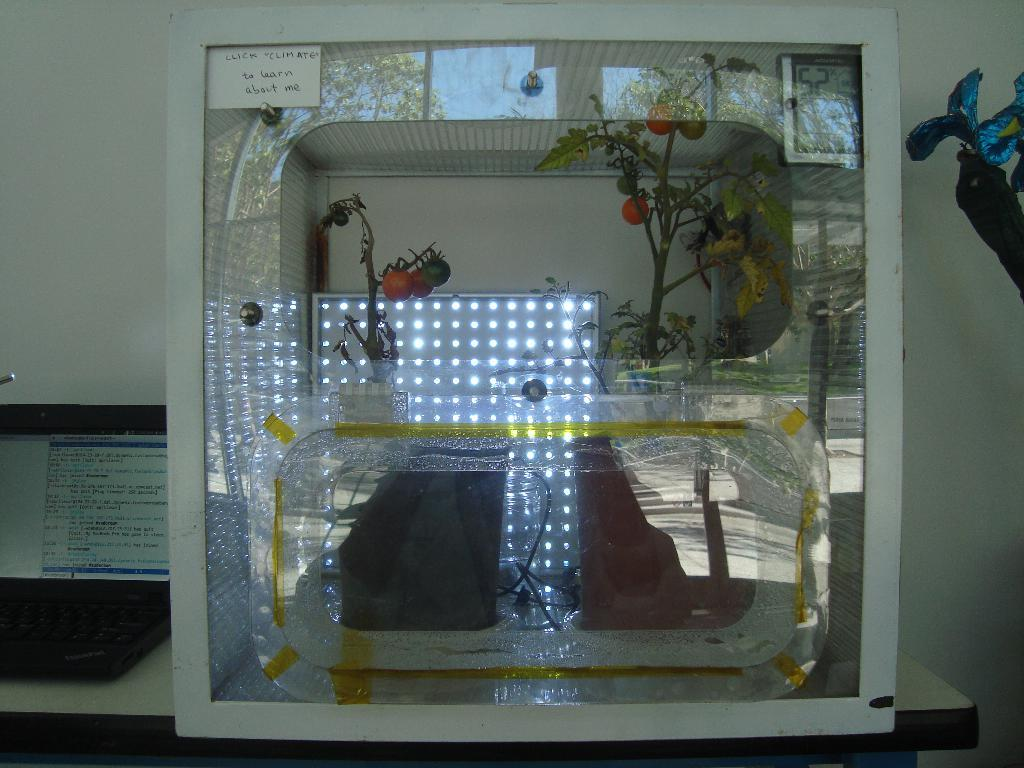What is the main object in the image? There is a box in the image. What is inside the box? There are plants and other unspecified items inside the box. What else can be seen in the image besides the box? There is a paper in the image. What is written on the paper? Something is written on the paper, but the specific content is not mentioned in the facts. What type of stick can be seen in the image? There is no stick present in the image. Where is the hall located in the image? There is no mention of a hall in the image or the provided facts. --- Facts: 1. There is a person in the image. 2. The person is wearing a hat. 3. The person is holding a book. 4. There is a table in the image. 5. The table has a lamp on it. Absurd Topics: parrot, ocean, mountain Conversation: Who is in the image? There is a person in the image. What is the person wearing? The person is wearing a hat. What is the person holding? The person is holding a book. What else can be seen in the image? There is a table in the image. What is on the table? The table has a lamp on it. Reasoning: Let's think step by step in order to produce the conversation. We start by identifying the main subject in the image, which is the person. Then, we describe what the person is wearing and holding, which are a hat and a book, respectively. Next, we mention the presence of the table in the image. Finally, we describe what is on the table, which is a lamp. Absurd Question/Answer: Can you see a parrot sitting on the person's shoulder in the image? There is no parrot present in the image. What type of ocean can be seen in the background of the image? There is no ocean present in the image. 